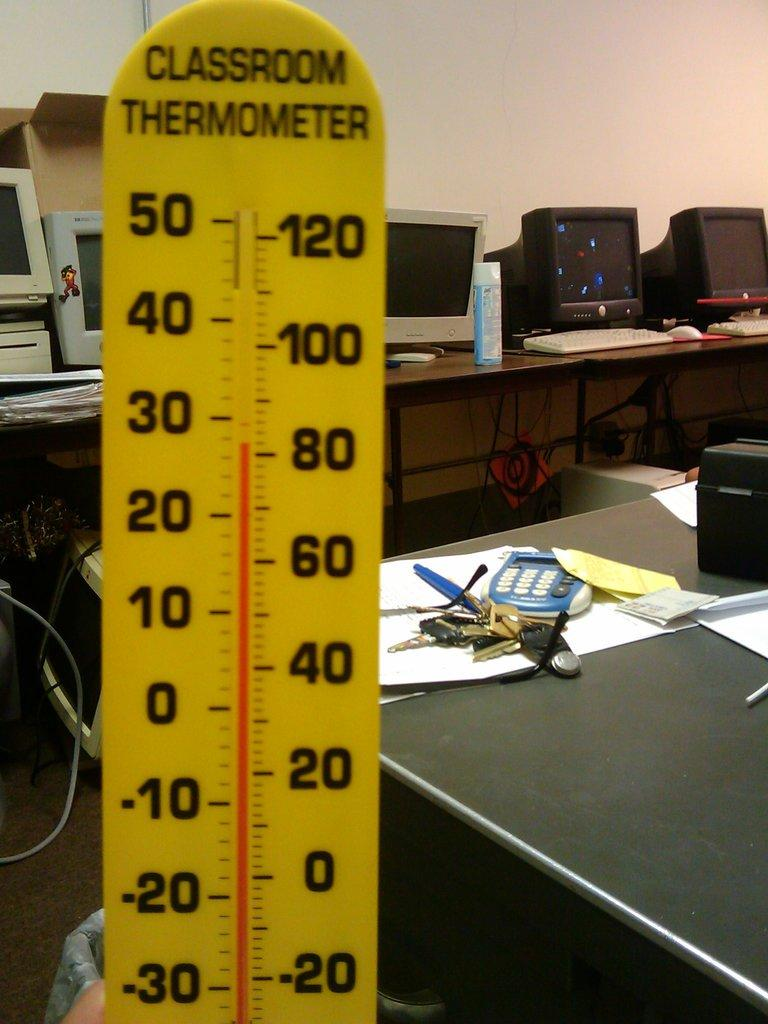<image>
Provide a brief description of the given image. many numbers that are on a large yellow item that says classroom thermometer 